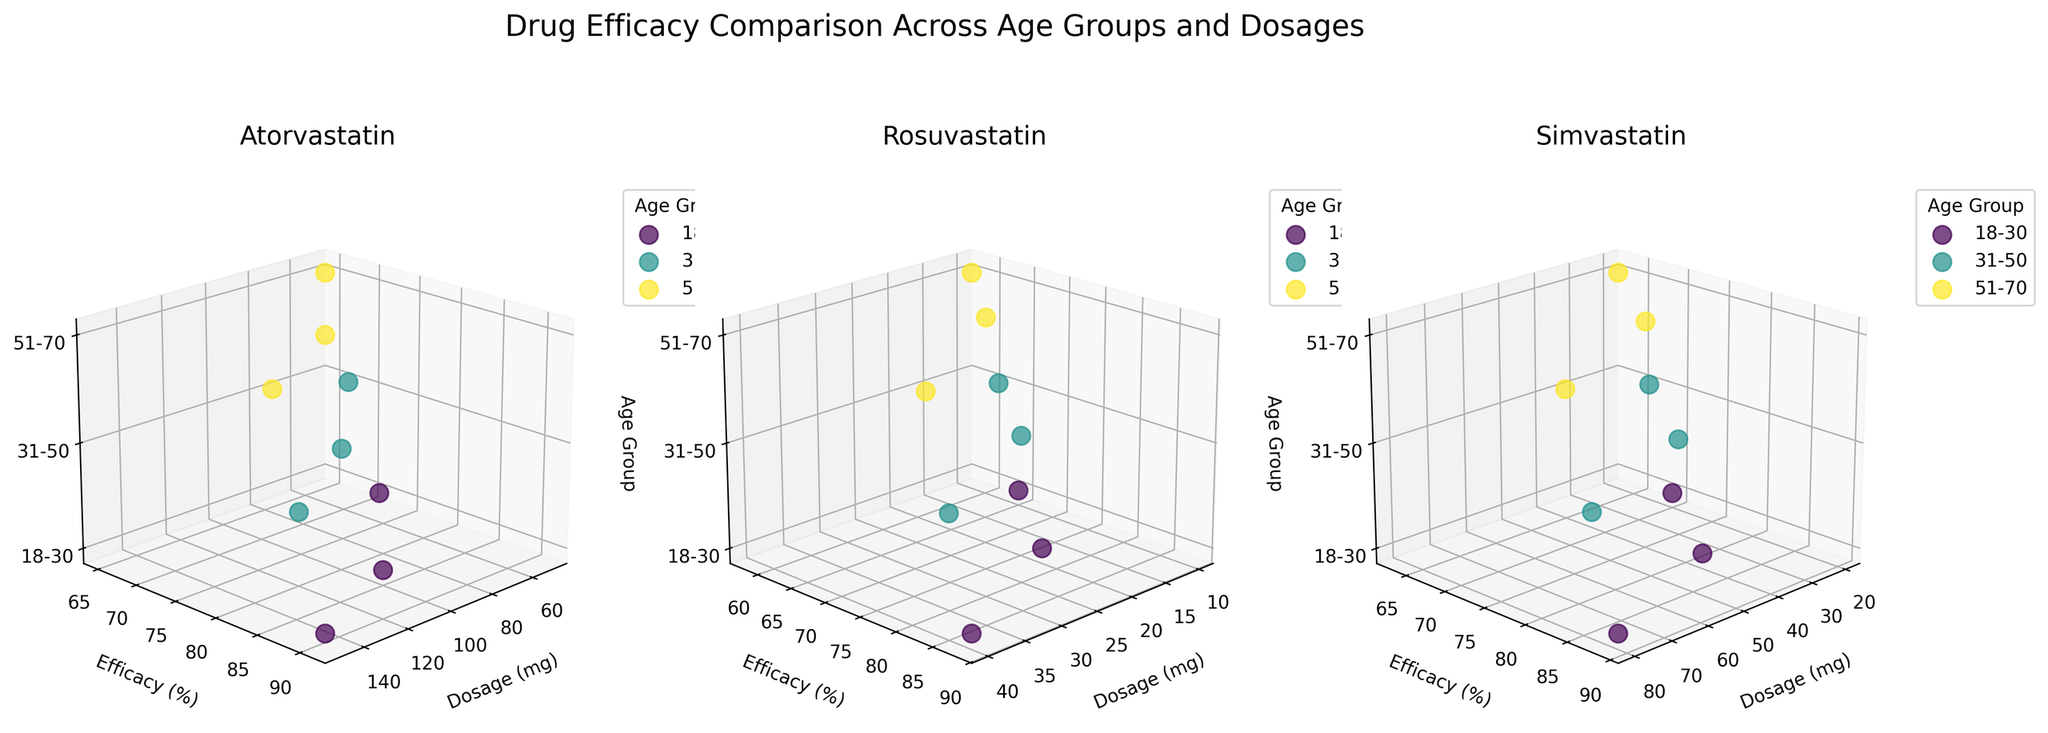How many medications are compared in the figure? The figure has three separate 3D plots, each representing a different medication.
Answer: 3 What are the age groups represented in the plots? The Z-axis of each subplot is marked with three age groups: '18-30', '31-50', and '51-70'.
Answer: '18-30', '31-50', '51-70' Which medication shows the highest efficacy for the '18-30' age group at the highest dosage? In the '18-30' age group, Atorvastatin has the highest efficacy of 91% at 150 mg, Rosuvastatin has 88% efficacy at 40 mg, and Simvastatin has 89% efficacy at 80 mg.
Answer: Atorvastatin For the medication Rosuvastatin, what is the efficacy difference between the '18-30' and '51-70' age groups at the 40 mg dosage? Look at the 40 mg dosage points for the '18-30' and '51-70' age groups. The efficacy for the '18-30' age group is 88%, and for the '51-70' age group, it is 82%. The difference is 88% - 82% = 6%.
Answer: 6% Which medication has the lowest efficacy recorded for the '31-50' age group, and at what dosage? For the '31-50' age group, look for the lowest efficacy percentage on each medication's subplot. Atorvastatin shows 68% efficacy at 50 mg, Rosuvastatin shows 62% efficacy at 10 mg, and Simvastatin shows 67% efficacy at 20 mg. The lowest is 62% for Rosuvastatin at 10 mg.
Answer: Rosuvastatin, 10 mg At what dosage does Simvastatin reach an 80% efficacy or higher for the '31-50' age group? Check Simvastatin's '31-50' age group plot for doses showing efficacy 80% or above. The 40 mg dosage shows 79% efficacy, which is under 80%. The 80 mg dosage shows 86% efficacy, which is above 80%.
Answer: 80 mg Which medication shows the least variability in efficacy across different dosages in the '51-70' age group? Assess the efficacy values for the '51-70' age group for each medication. Atorvastatin ranges from 65% to 85%, Rosuvastatin from 58% to 82%, and Simvastatin from 63% to 83%. The range for Simvastatin is the smallest (63% to 83%), indicating the least variability.
Answer: Simvastatin Is there any dosage level where all medications reach at least 75% efficacy for the '31-50' age group? Check for each dosage in the '31-50' age group to see if efficacy is 75% or higher across all medications. For 50 mg Atorvastatin, efficacy is 68%, which is below 75%. At 100 mg and above dosages of Atorvastatin, efficacy is above 75%. For Rosuvastatin, 20 mg shows 75%, and 40 mg shows 85%. For Simvastatin, 40 mg shows 79%. Thus, none meets this criterion.
Answer: No 